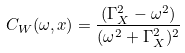Convert formula to latex. <formula><loc_0><loc_0><loc_500><loc_500>C _ { W } ( \omega , x ) = \frac { ( \Gamma _ { X } ^ { 2 } - \omega ^ { 2 } ) } { ( \omega ^ { 2 } + \Gamma _ { X } ^ { 2 } ) ^ { 2 } }</formula> 